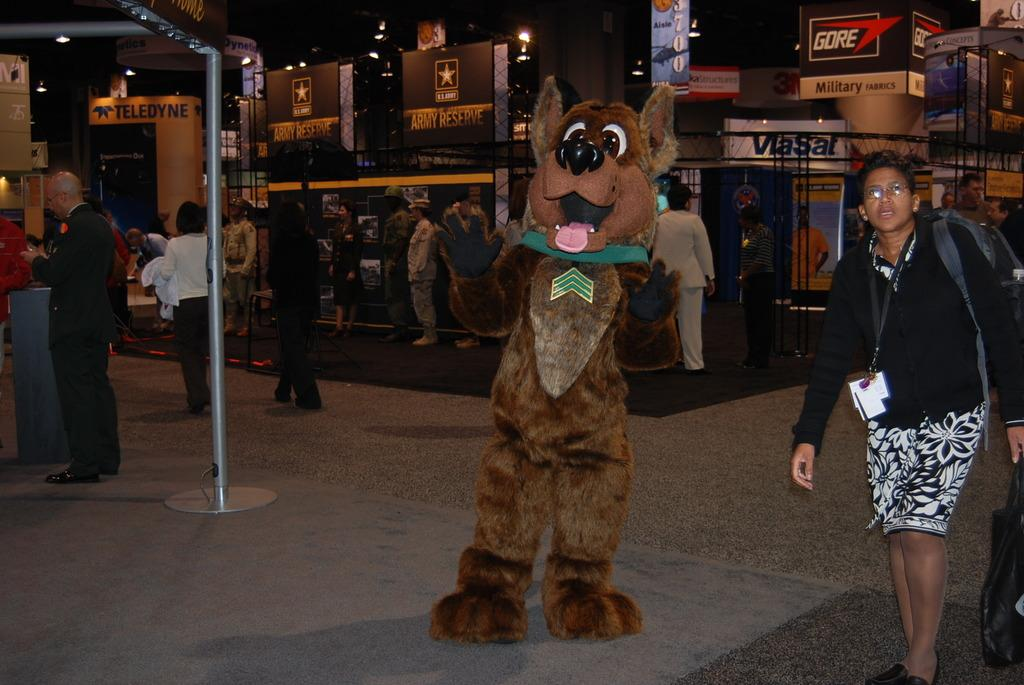What is the person in the image dressed as? The person in the image is wearing a costume of an animal. What can be seen happening in the background of the image? There are people walking in the background of the image. What is located on the left side of the image? There is a pole on the left side of the image. How many eyes can be seen on the cracker in the image? There is no cracker present in the image, so it is not possible to determine the number of eyes on it. 